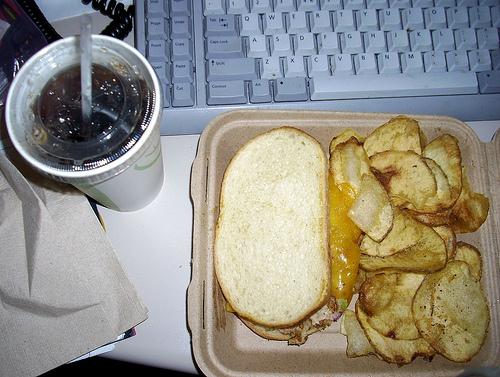Was this a take out meal?
Answer briefly. Yes. Is this a grilled cheese?
Keep it brief. Yes. What is in the cup?
Answer briefly. Soda. 